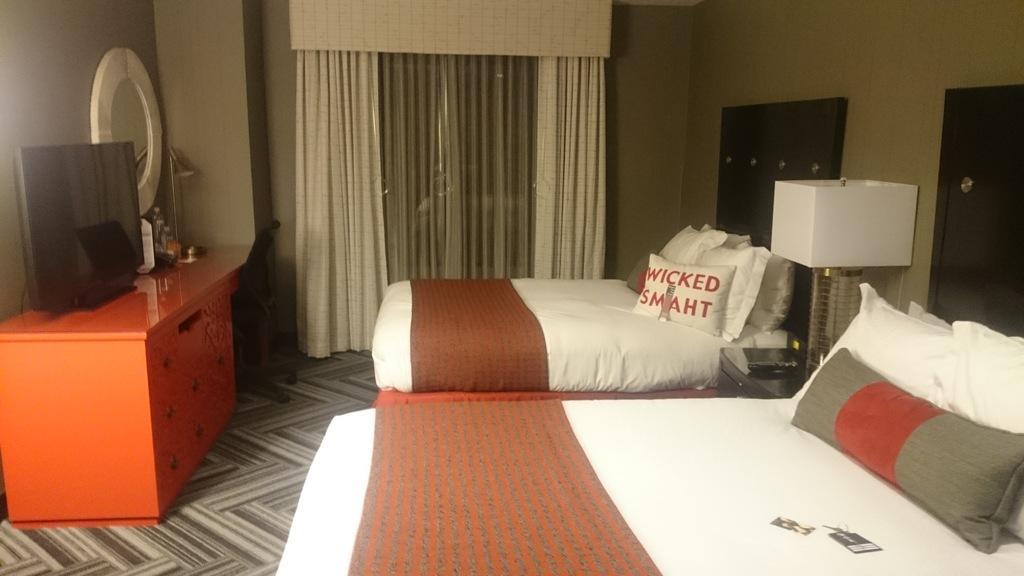Please provide a concise description of this image. The image is taken inside a room. There are beds in the room. On the left there is a table and a television placed on the table. There is a mirror attached to a wall. There is a chair. There are pillows on the bed. 